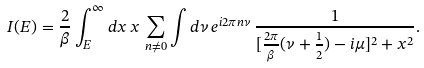<formula> <loc_0><loc_0><loc_500><loc_500>I ( E ) = \frac { 2 } { \beta } \int _ { E } ^ { \infty } d x \, x \, \sum _ { n \not = 0 } \int d \nu \, e ^ { i 2 \pi n \nu } \, \frac { 1 } { [ \frac { 2 \pi } { \beta } ( \nu + \frac { 1 } { 2 } ) - i \mu ] ^ { 2 } + x ^ { 2 } } .</formula> 